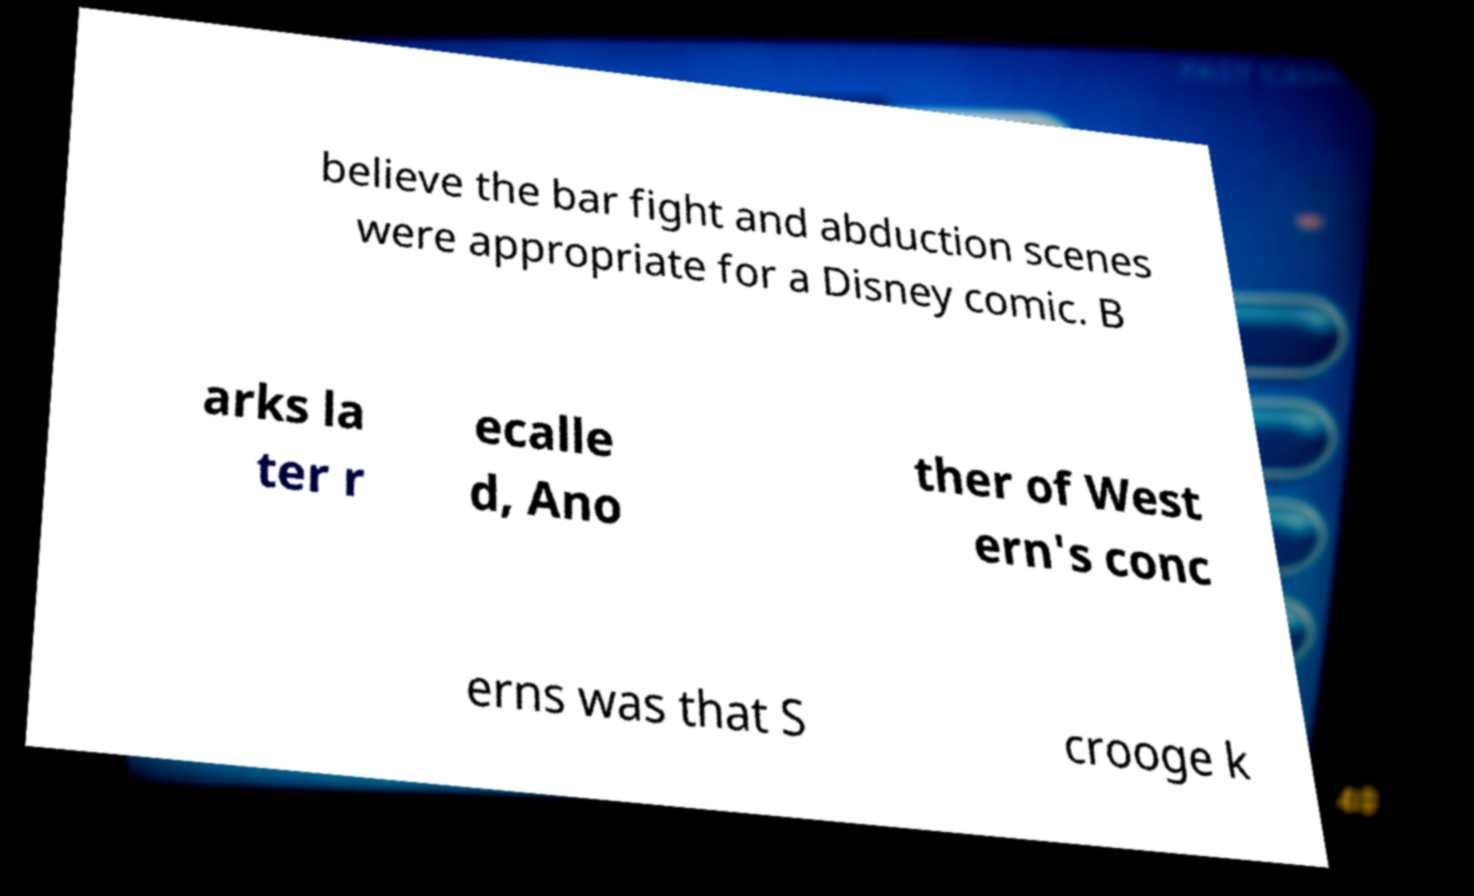For documentation purposes, I need the text within this image transcribed. Could you provide that? believe the bar fight and abduction scenes were appropriate for a Disney comic. B arks la ter r ecalle d, Ano ther of West ern's conc erns was that S crooge k 